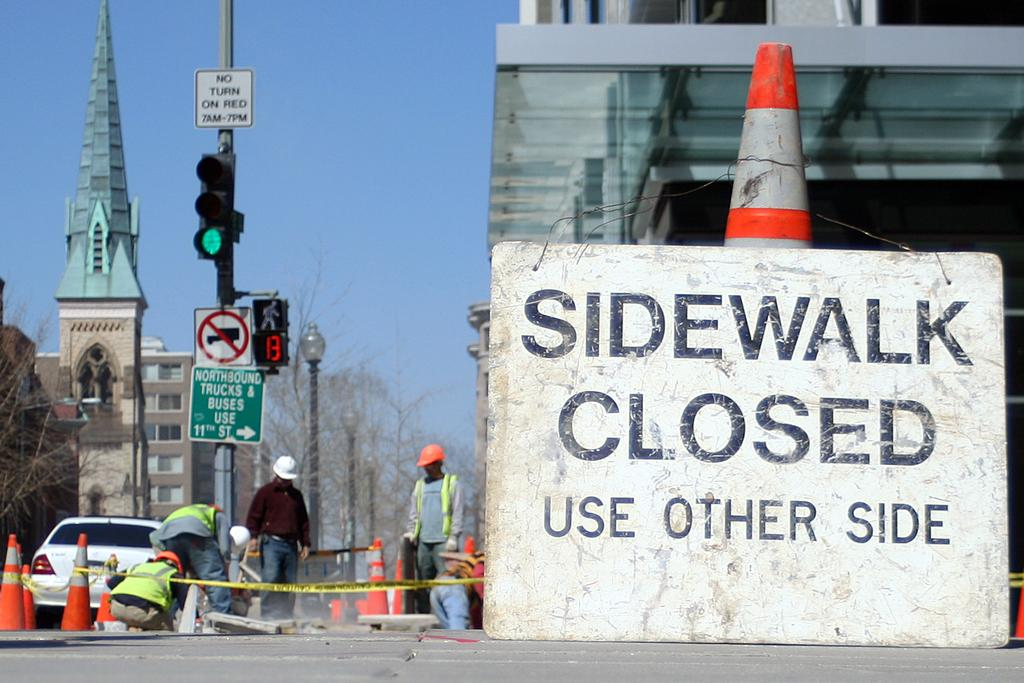<image>
Give a short and clear explanation of the subsequent image. A large sign says "Sidewalk Closed" near a construction zone 